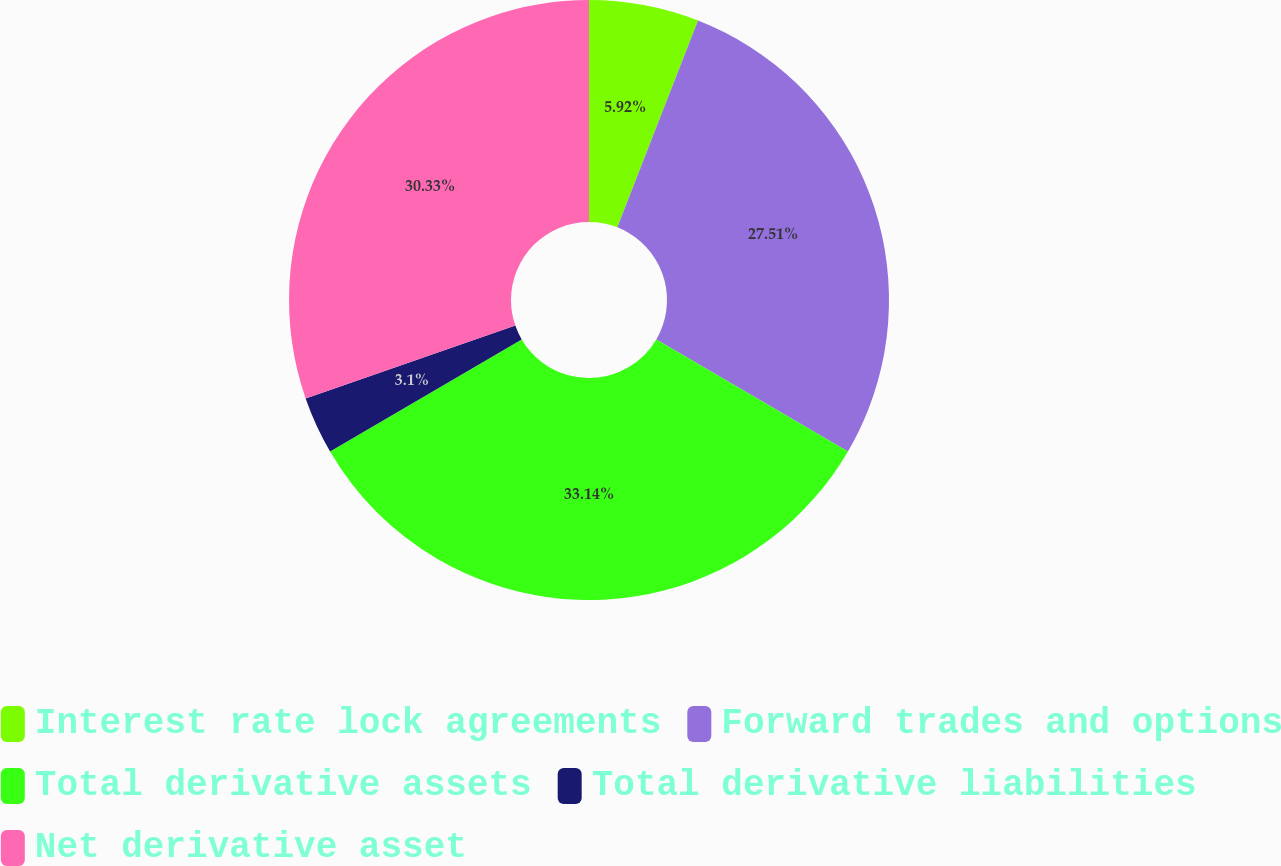Convert chart. <chart><loc_0><loc_0><loc_500><loc_500><pie_chart><fcel>Interest rate lock agreements<fcel>Forward trades and options<fcel>Total derivative assets<fcel>Total derivative liabilities<fcel>Net derivative asset<nl><fcel>5.92%<fcel>27.51%<fcel>33.15%<fcel>3.1%<fcel>30.33%<nl></chart> 